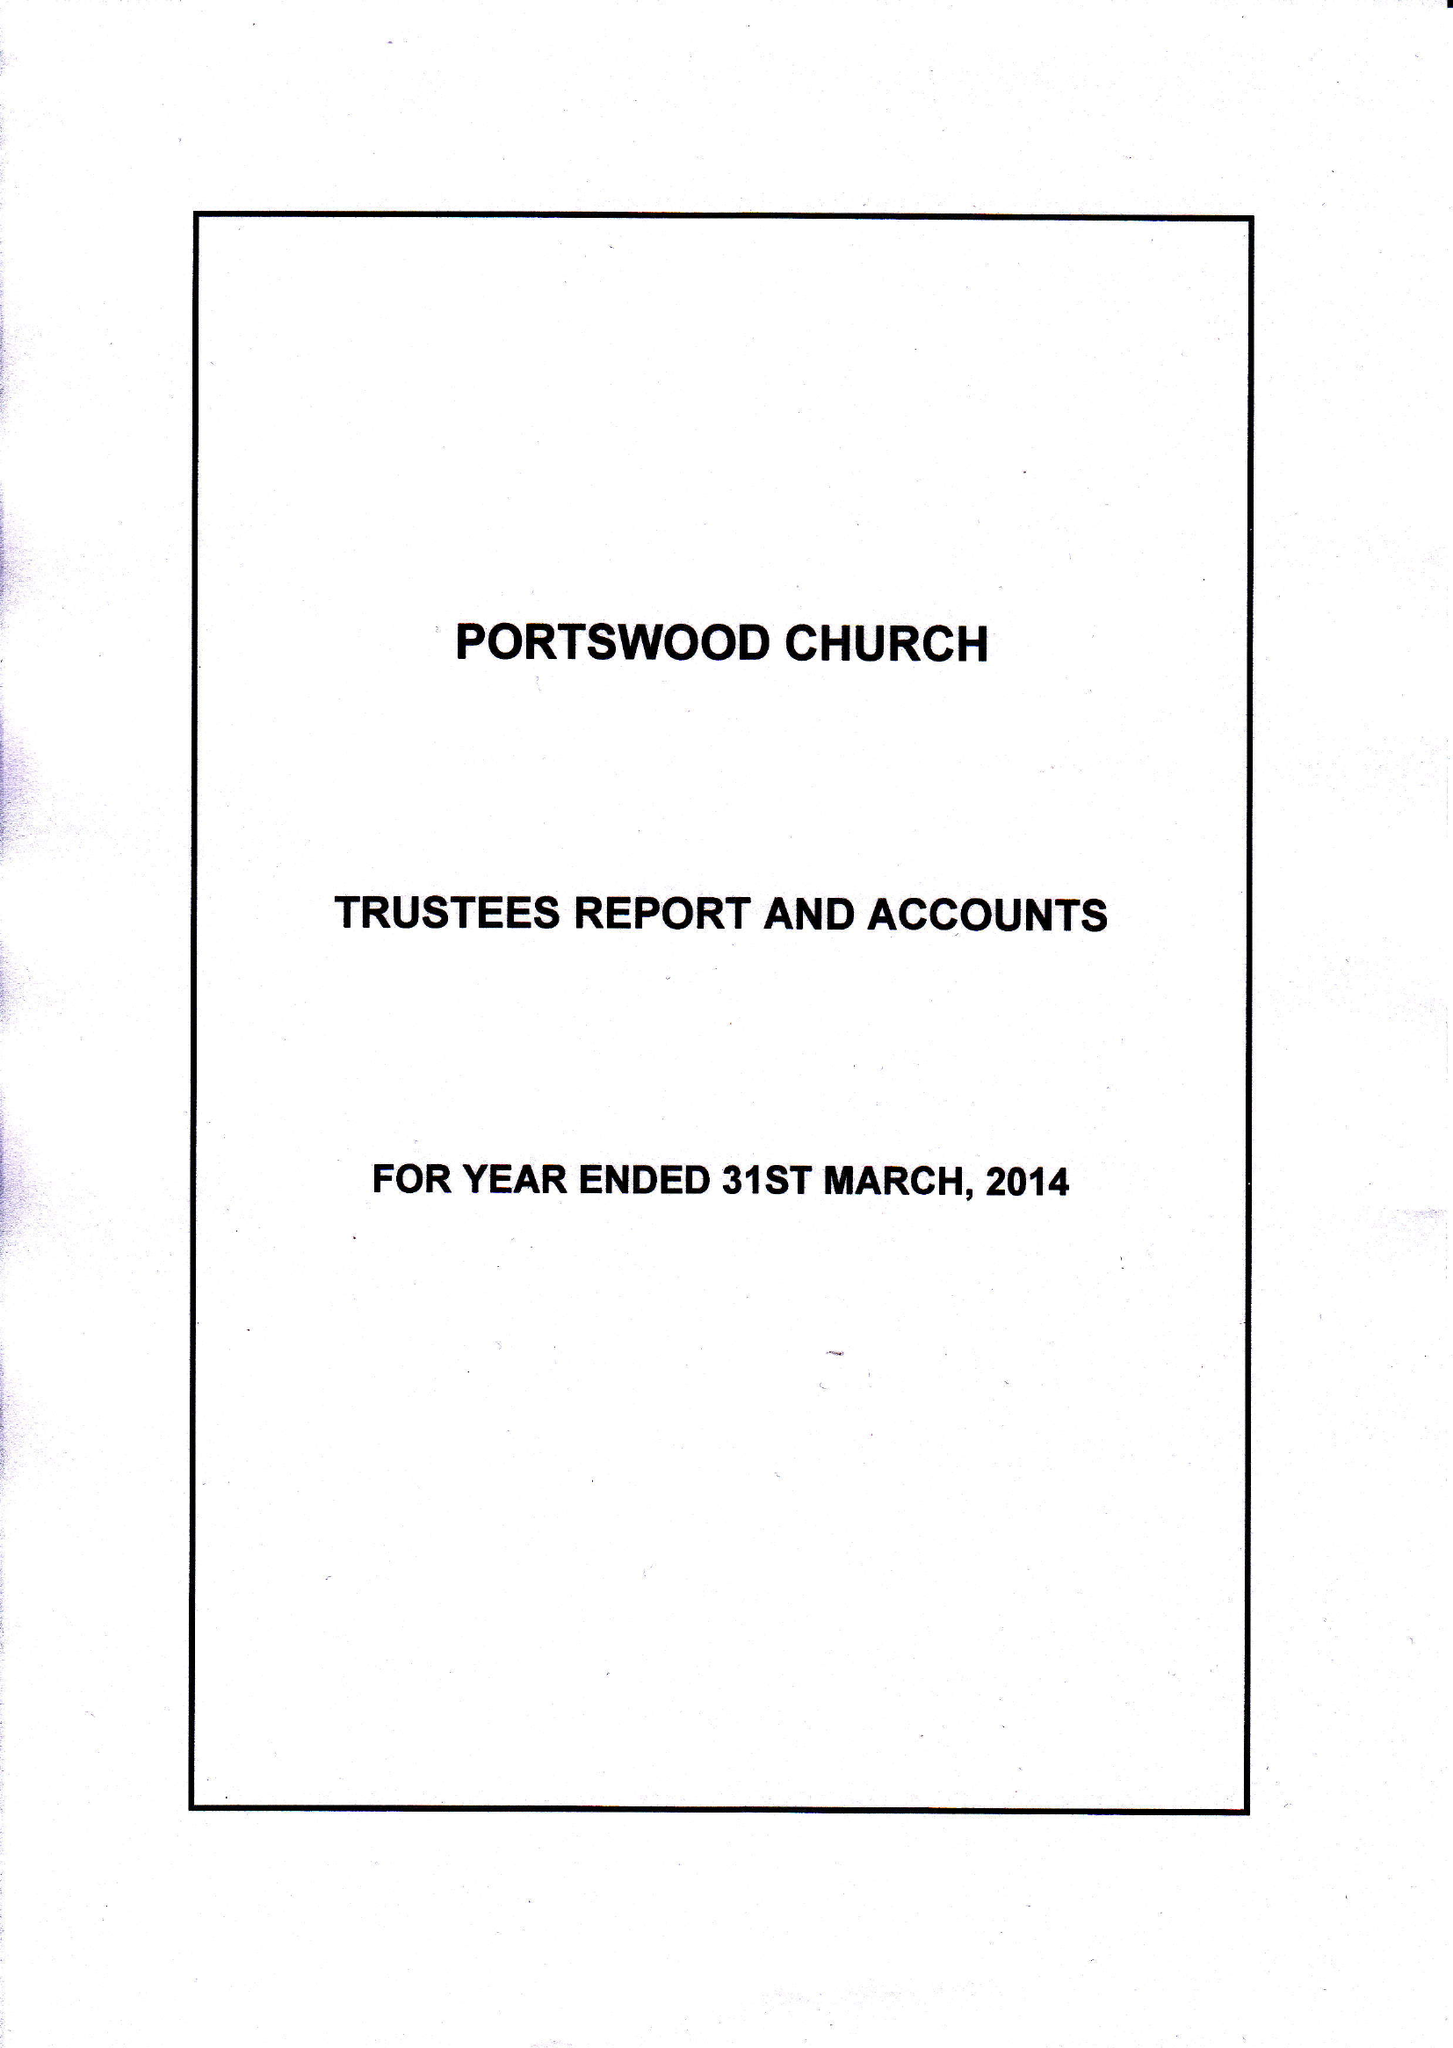What is the value for the report_date?
Answer the question using a single word or phrase. 2014-03-31 